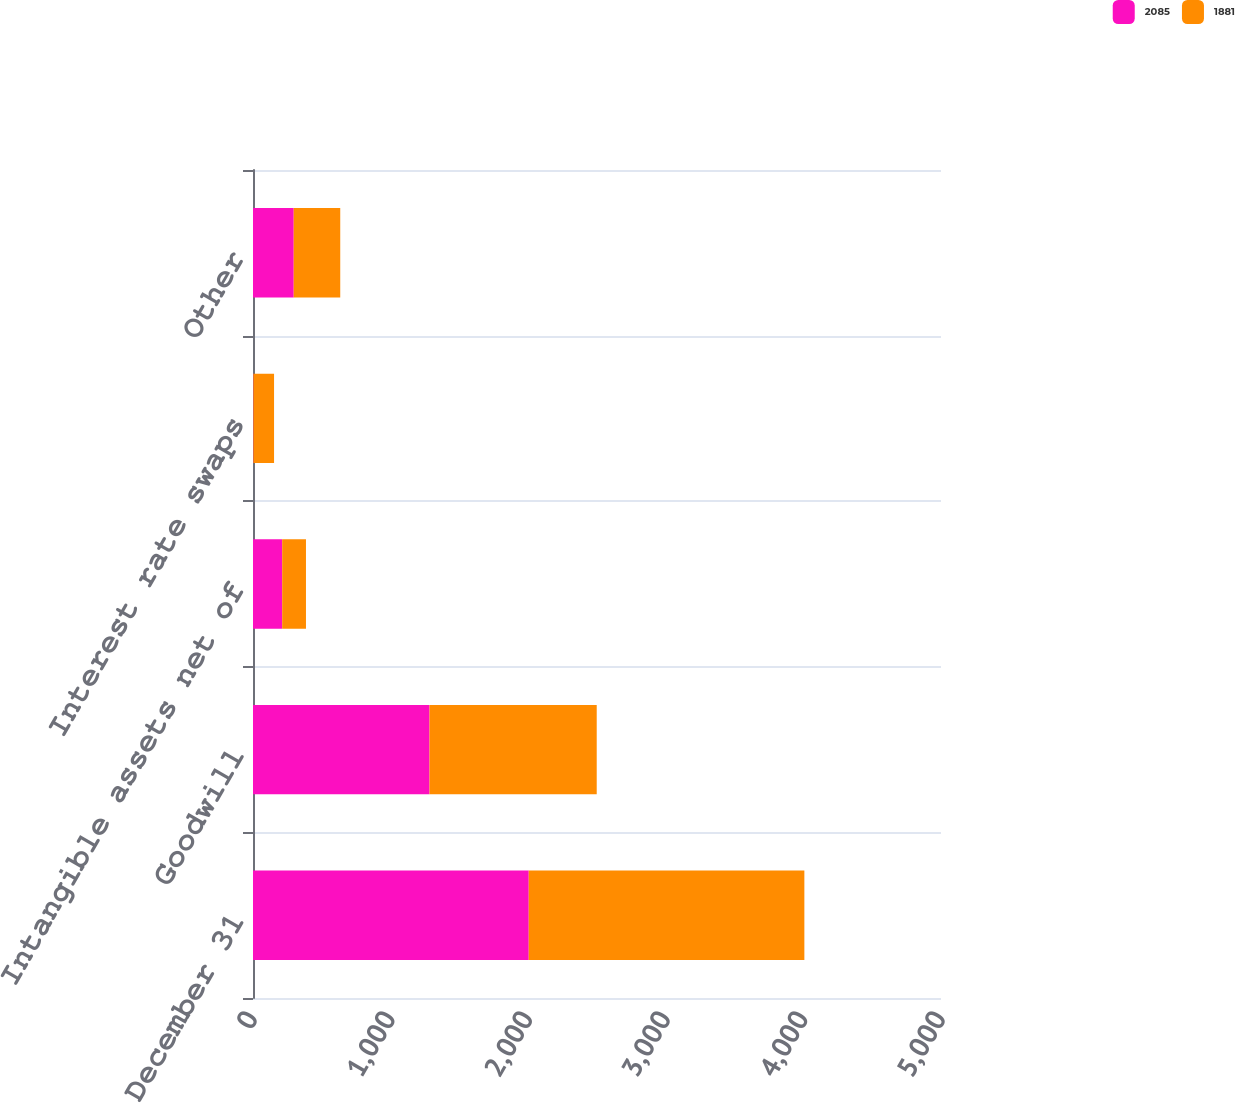Convert chart to OTSL. <chart><loc_0><loc_0><loc_500><loc_500><stacked_bar_chart><ecel><fcel>December 31<fcel>Goodwill<fcel>Intangible assets net of<fcel>Interest rate swaps<fcel>Other<nl><fcel>2085<fcel>2004<fcel>1283<fcel>212<fcel>3<fcel>296<nl><fcel>1881<fcel>2003<fcel>1215<fcel>173<fcel>150<fcel>338<nl></chart> 